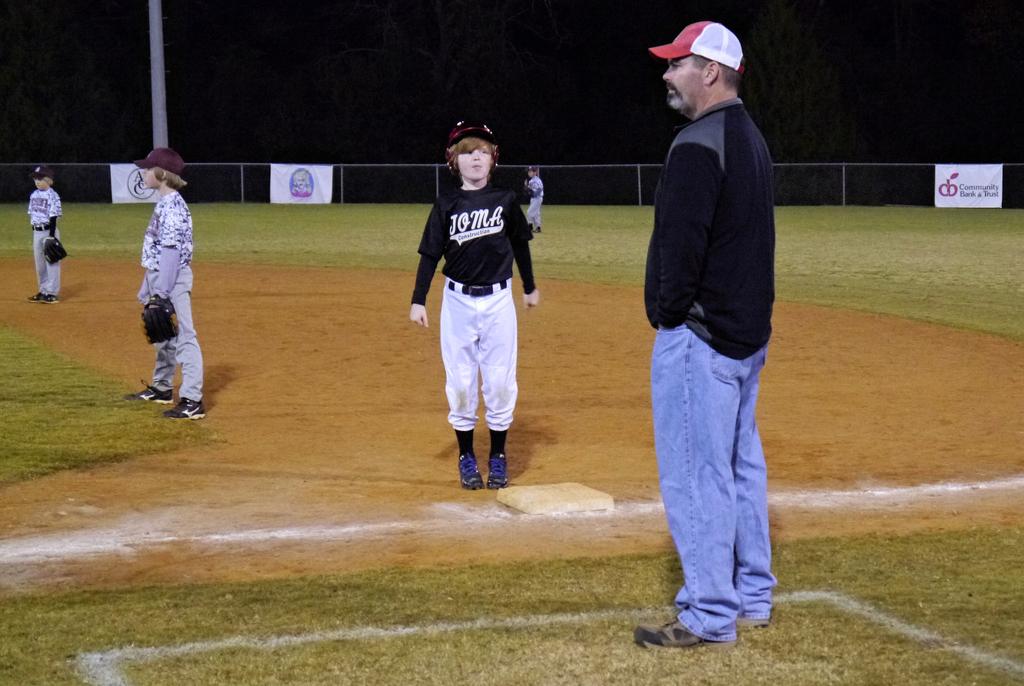What's the team name on the boy's shirt?
Give a very brief answer. Joma. 